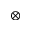Convert formula to latex. <formula><loc_0><loc_0><loc_500><loc_500>\otimes</formula> 